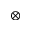Convert formula to latex. <formula><loc_0><loc_0><loc_500><loc_500>\otimes</formula> 